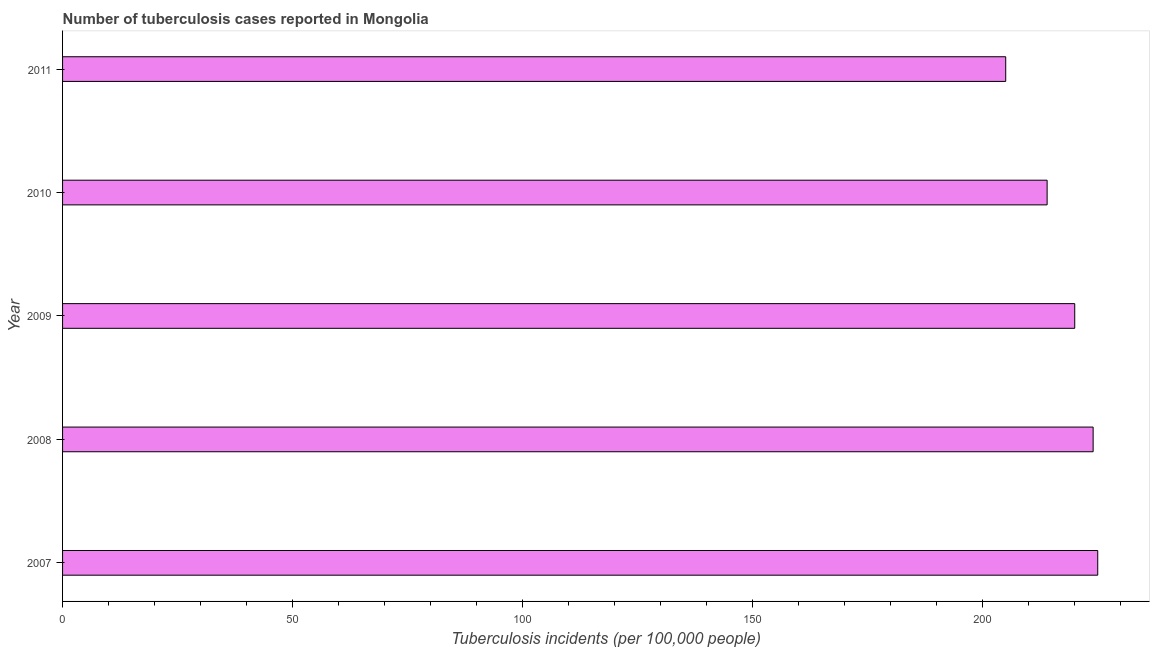Does the graph contain grids?
Keep it short and to the point. No. What is the title of the graph?
Provide a short and direct response. Number of tuberculosis cases reported in Mongolia. What is the label or title of the X-axis?
Your response must be concise. Tuberculosis incidents (per 100,0 people). What is the label or title of the Y-axis?
Provide a succinct answer. Year. What is the number of tuberculosis incidents in 2011?
Your response must be concise. 205. Across all years, what is the maximum number of tuberculosis incidents?
Your answer should be very brief. 225. Across all years, what is the minimum number of tuberculosis incidents?
Offer a terse response. 205. What is the sum of the number of tuberculosis incidents?
Offer a very short reply. 1088. What is the difference between the number of tuberculosis incidents in 2008 and 2011?
Offer a terse response. 19. What is the average number of tuberculosis incidents per year?
Your response must be concise. 217. What is the median number of tuberculosis incidents?
Your answer should be very brief. 220. Do a majority of the years between 2009 and 2011 (inclusive) have number of tuberculosis incidents greater than 80 ?
Keep it short and to the point. Yes. What is the ratio of the number of tuberculosis incidents in 2007 to that in 2009?
Your answer should be compact. 1.02. Is the difference between the number of tuberculosis incidents in 2008 and 2011 greater than the difference between any two years?
Your response must be concise. No. What is the difference between the highest and the lowest number of tuberculosis incidents?
Make the answer very short. 20. In how many years, is the number of tuberculosis incidents greater than the average number of tuberculosis incidents taken over all years?
Your answer should be very brief. 3. How many bars are there?
Your answer should be compact. 5. What is the difference between two consecutive major ticks on the X-axis?
Offer a very short reply. 50. Are the values on the major ticks of X-axis written in scientific E-notation?
Make the answer very short. No. What is the Tuberculosis incidents (per 100,000 people) in 2007?
Keep it short and to the point. 225. What is the Tuberculosis incidents (per 100,000 people) in 2008?
Offer a very short reply. 224. What is the Tuberculosis incidents (per 100,000 people) of 2009?
Make the answer very short. 220. What is the Tuberculosis incidents (per 100,000 people) of 2010?
Keep it short and to the point. 214. What is the Tuberculosis incidents (per 100,000 people) in 2011?
Provide a succinct answer. 205. What is the difference between the Tuberculosis incidents (per 100,000 people) in 2008 and 2009?
Make the answer very short. 4. What is the difference between the Tuberculosis incidents (per 100,000 people) in 2008 and 2010?
Your response must be concise. 10. What is the difference between the Tuberculosis incidents (per 100,000 people) in 2008 and 2011?
Give a very brief answer. 19. What is the difference between the Tuberculosis incidents (per 100,000 people) in 2010 and 2011?
Make the answer very short. 9. What is the ratio of the Tuberculosis incidents (per 100,000 people) in 2007 to that in 2008?
Your response must be concise. 1. What is the ratio of the Tuberculosis incidents (per 100,000 people) in 2007 to that in 2009?
Offer a terse response. 1.02. What is the ratio of the Tuberculosis incidents (per 100,000 people) in 2007 to that in 2010?
Your answer should be compact. 1.05. What is the ratio of the Tuberculosis incidents (per 100,000 people) in 2007 to that in 2011?
Offer a terse response. 1.1. What is the ratio of the Tuberculosis incidents (per 100,000 people) in 2008 to that in 2010?
Provide a short and direct response. 1.05. What is the ratio of the Tuberculosis incidents (per 100,000 people) in 2008 to that in 2011?
Your answer should be compact. 1.09. What is the ratio of the Tuberculosis incidents (per 100,000 people) in 2009 to that in 2010?
Offer a terse response. 1.03. What is the ratio of the Tuberculosis incidents (per 100,000 people) in 2009 to that in 2011?
Your answer should be compact. 1.07. What is the ratio of the Tuberculosis incidents (per 100,000 people) in 2010 to that in 2011?
Make the answer very short. 1.04. 